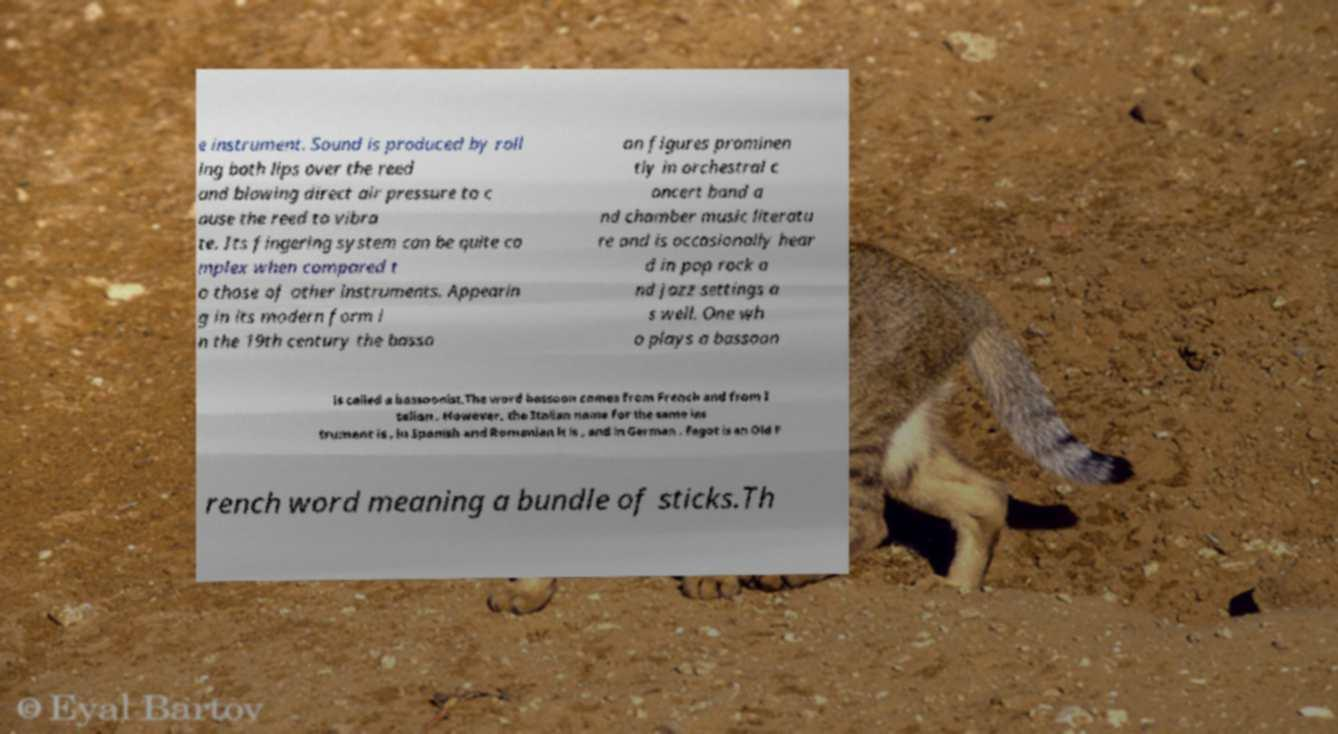Can you read and provide the text displayed in the image?This photo seems to have some interesting text. Can you extract and type it out for me? e instrument. Sound is produced by roll ing both lips over the reed and blowing direct air pressure to c ause the reed to vibra te. Its fingering system can be quite co mplex when compared t o those of other instruments. Appearin g in its modern form i n the 19th century the basso on figures prominen tly in orchestral c oncert band a nd chamber music literatu re and is occasionally hear d in pop rock a nd jazz settings a s well. One wh o plays a bassoon is called a bassoonist.The word bassoon comes from French and from I talian . However, the Italian name for the same ins trument is , in Spanish and Romanian it is , and in German . Fagot is an Old F rench word meaning a bundle of sticks.Th 